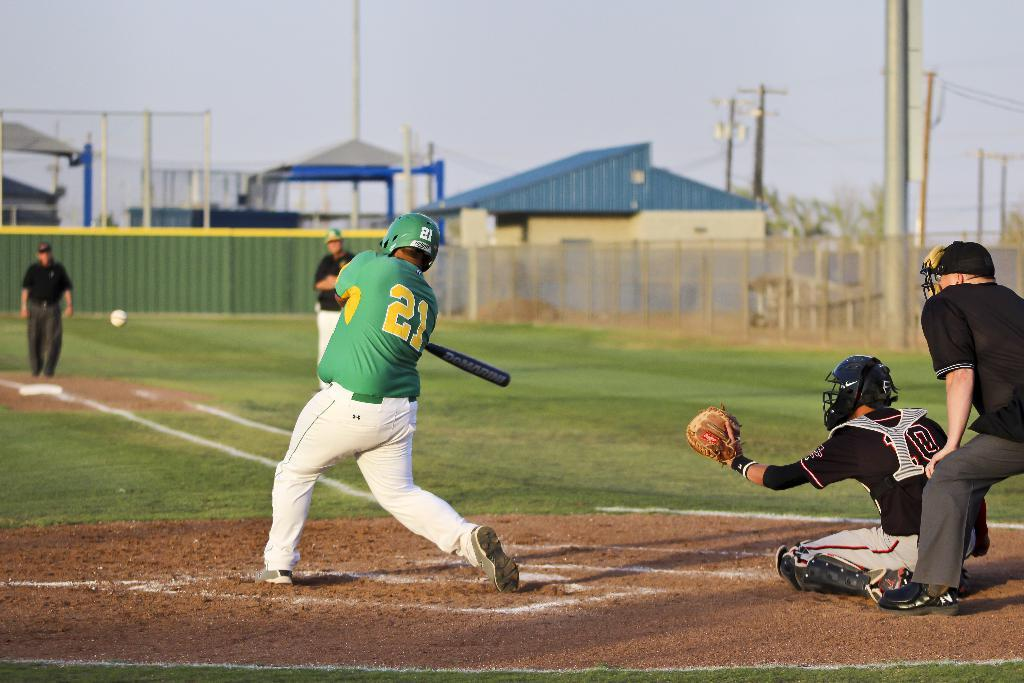<image>
Offer a succinct explanation of the picture presented. A baseball player with the number 21 on his back 